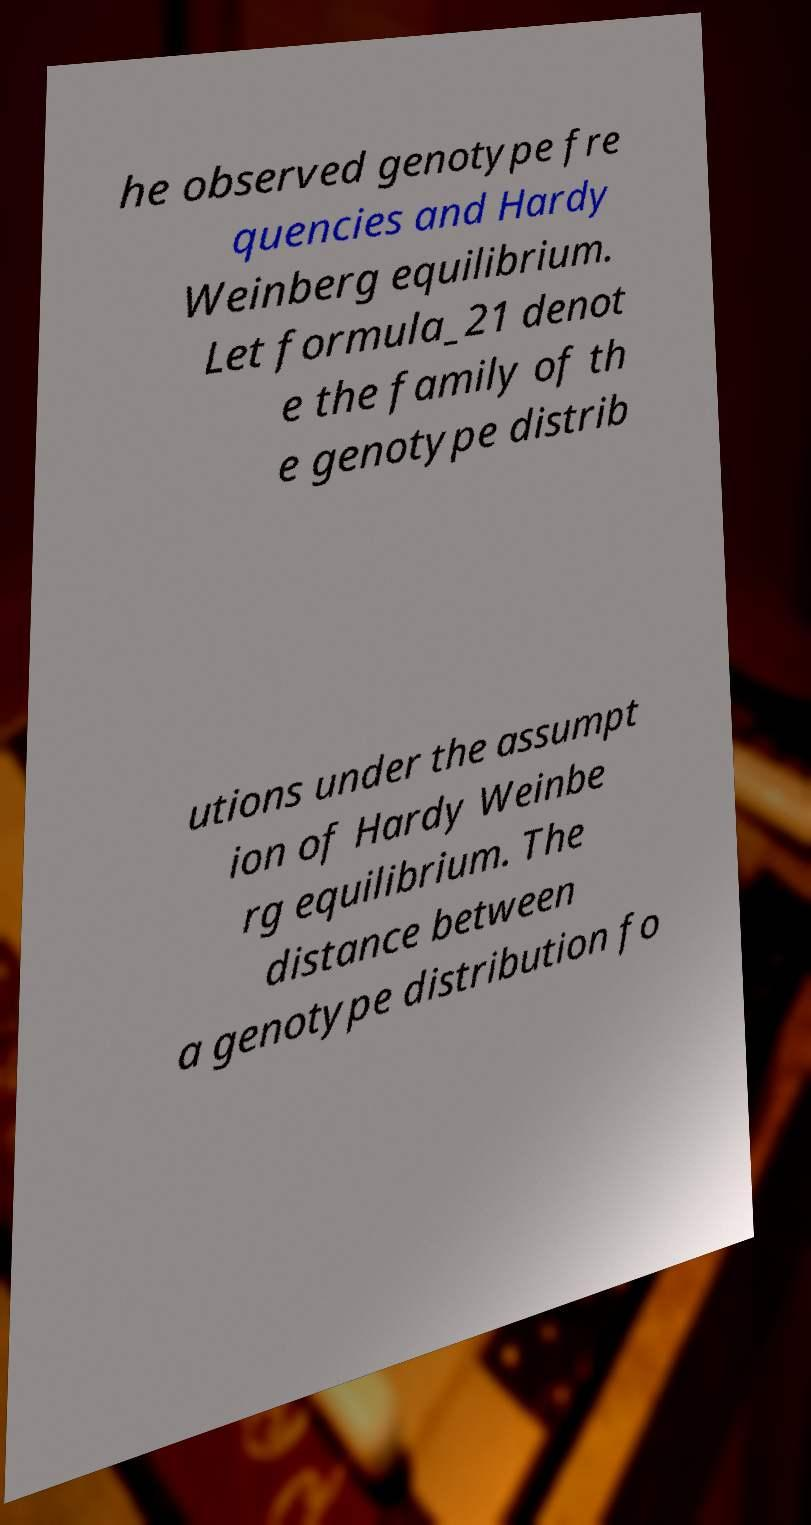Please read and relay the text visible in this image. What does it say? he observed genotype fre quencies and Hardy Weinberg equilibrium. Let formula_21 denot e the family of th e genotype distrib utions under the assumpt ion of Hardy Weinbe rg equilibrium. The distance between a genotype distribution fo 